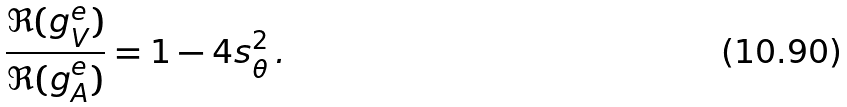Convert formula to latex. <formula><loc_0><loc_0><loc_500><loc_500>\frac { \Re ( g _ { V } ^ { e } ) } { \Re ( g _ { A } ^ { e } ) } = 1 - 4 s _ { \theta } ^ { 2 } \, .</formula> 